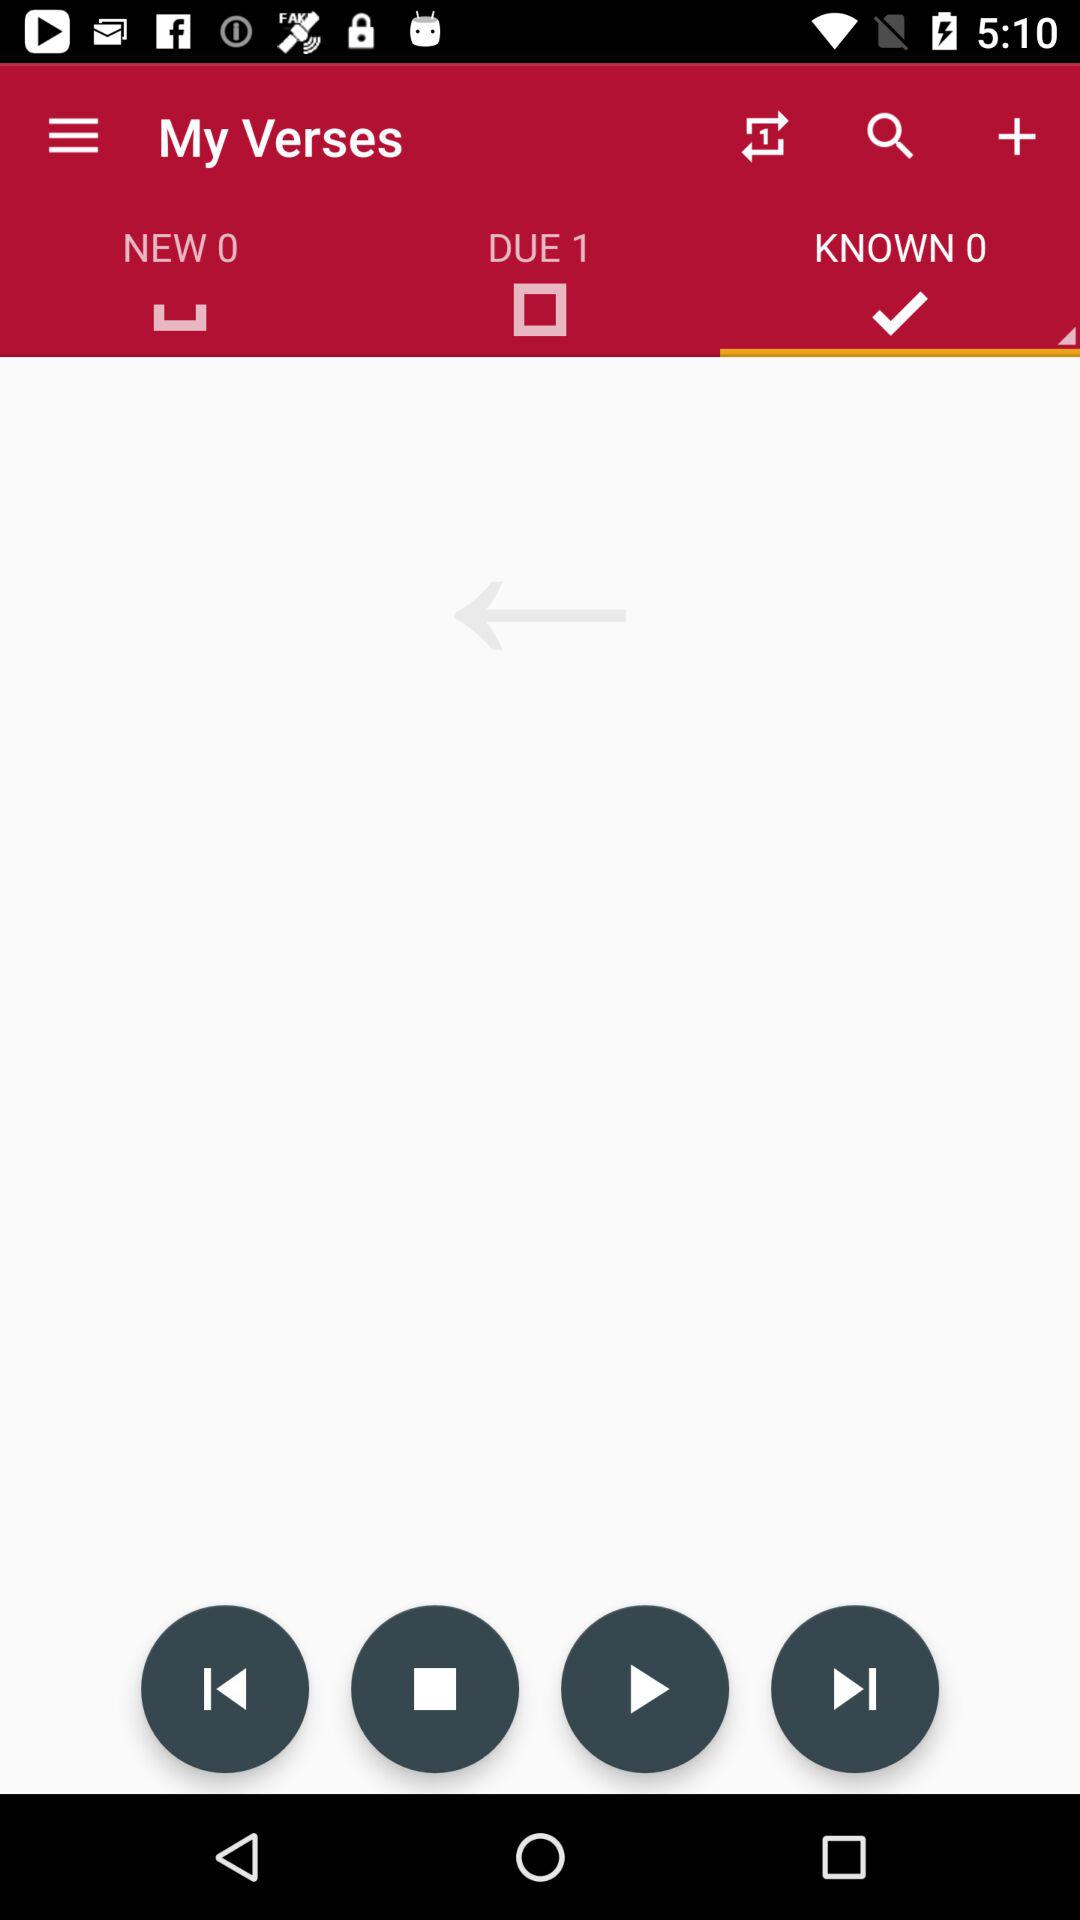What is the name of the application? The name of the application is "My Verses". 